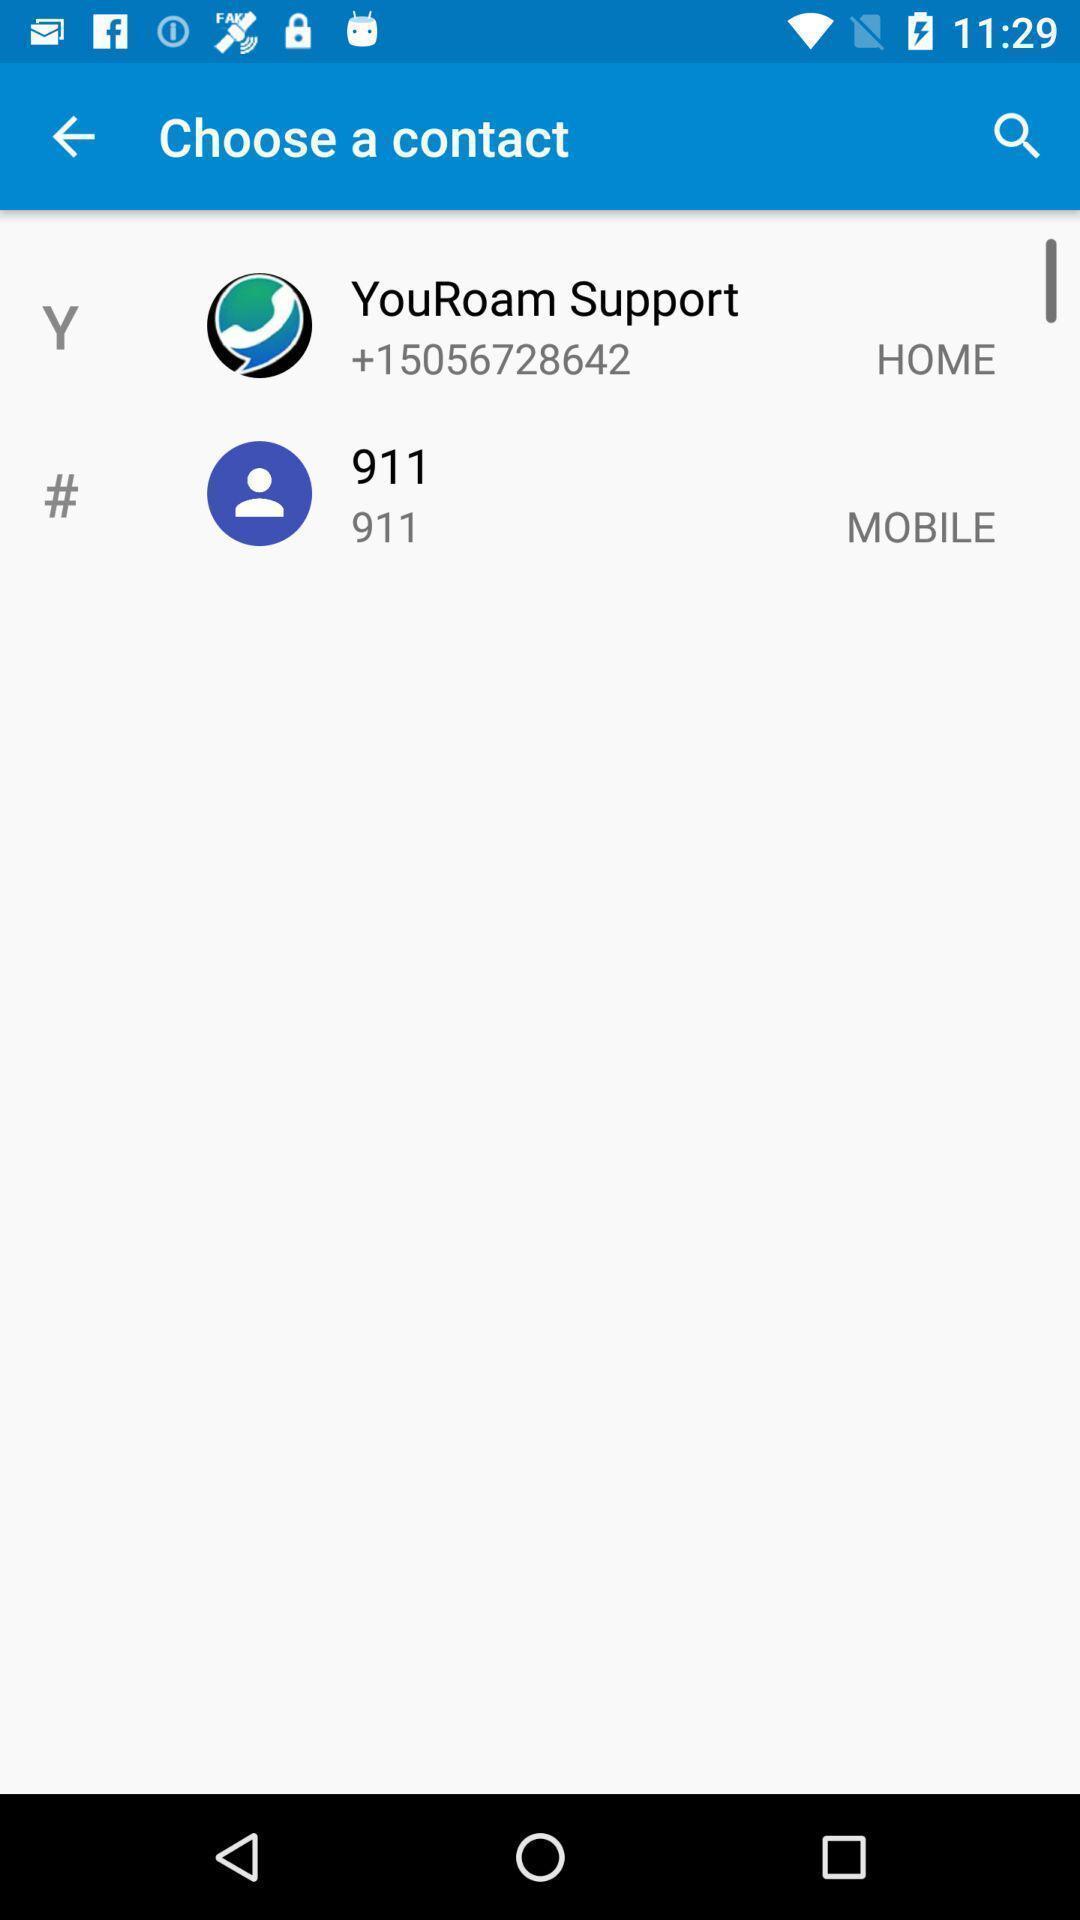Describe the visual elements of this screenshot. Page displaying to choose a contact of an dating application. 